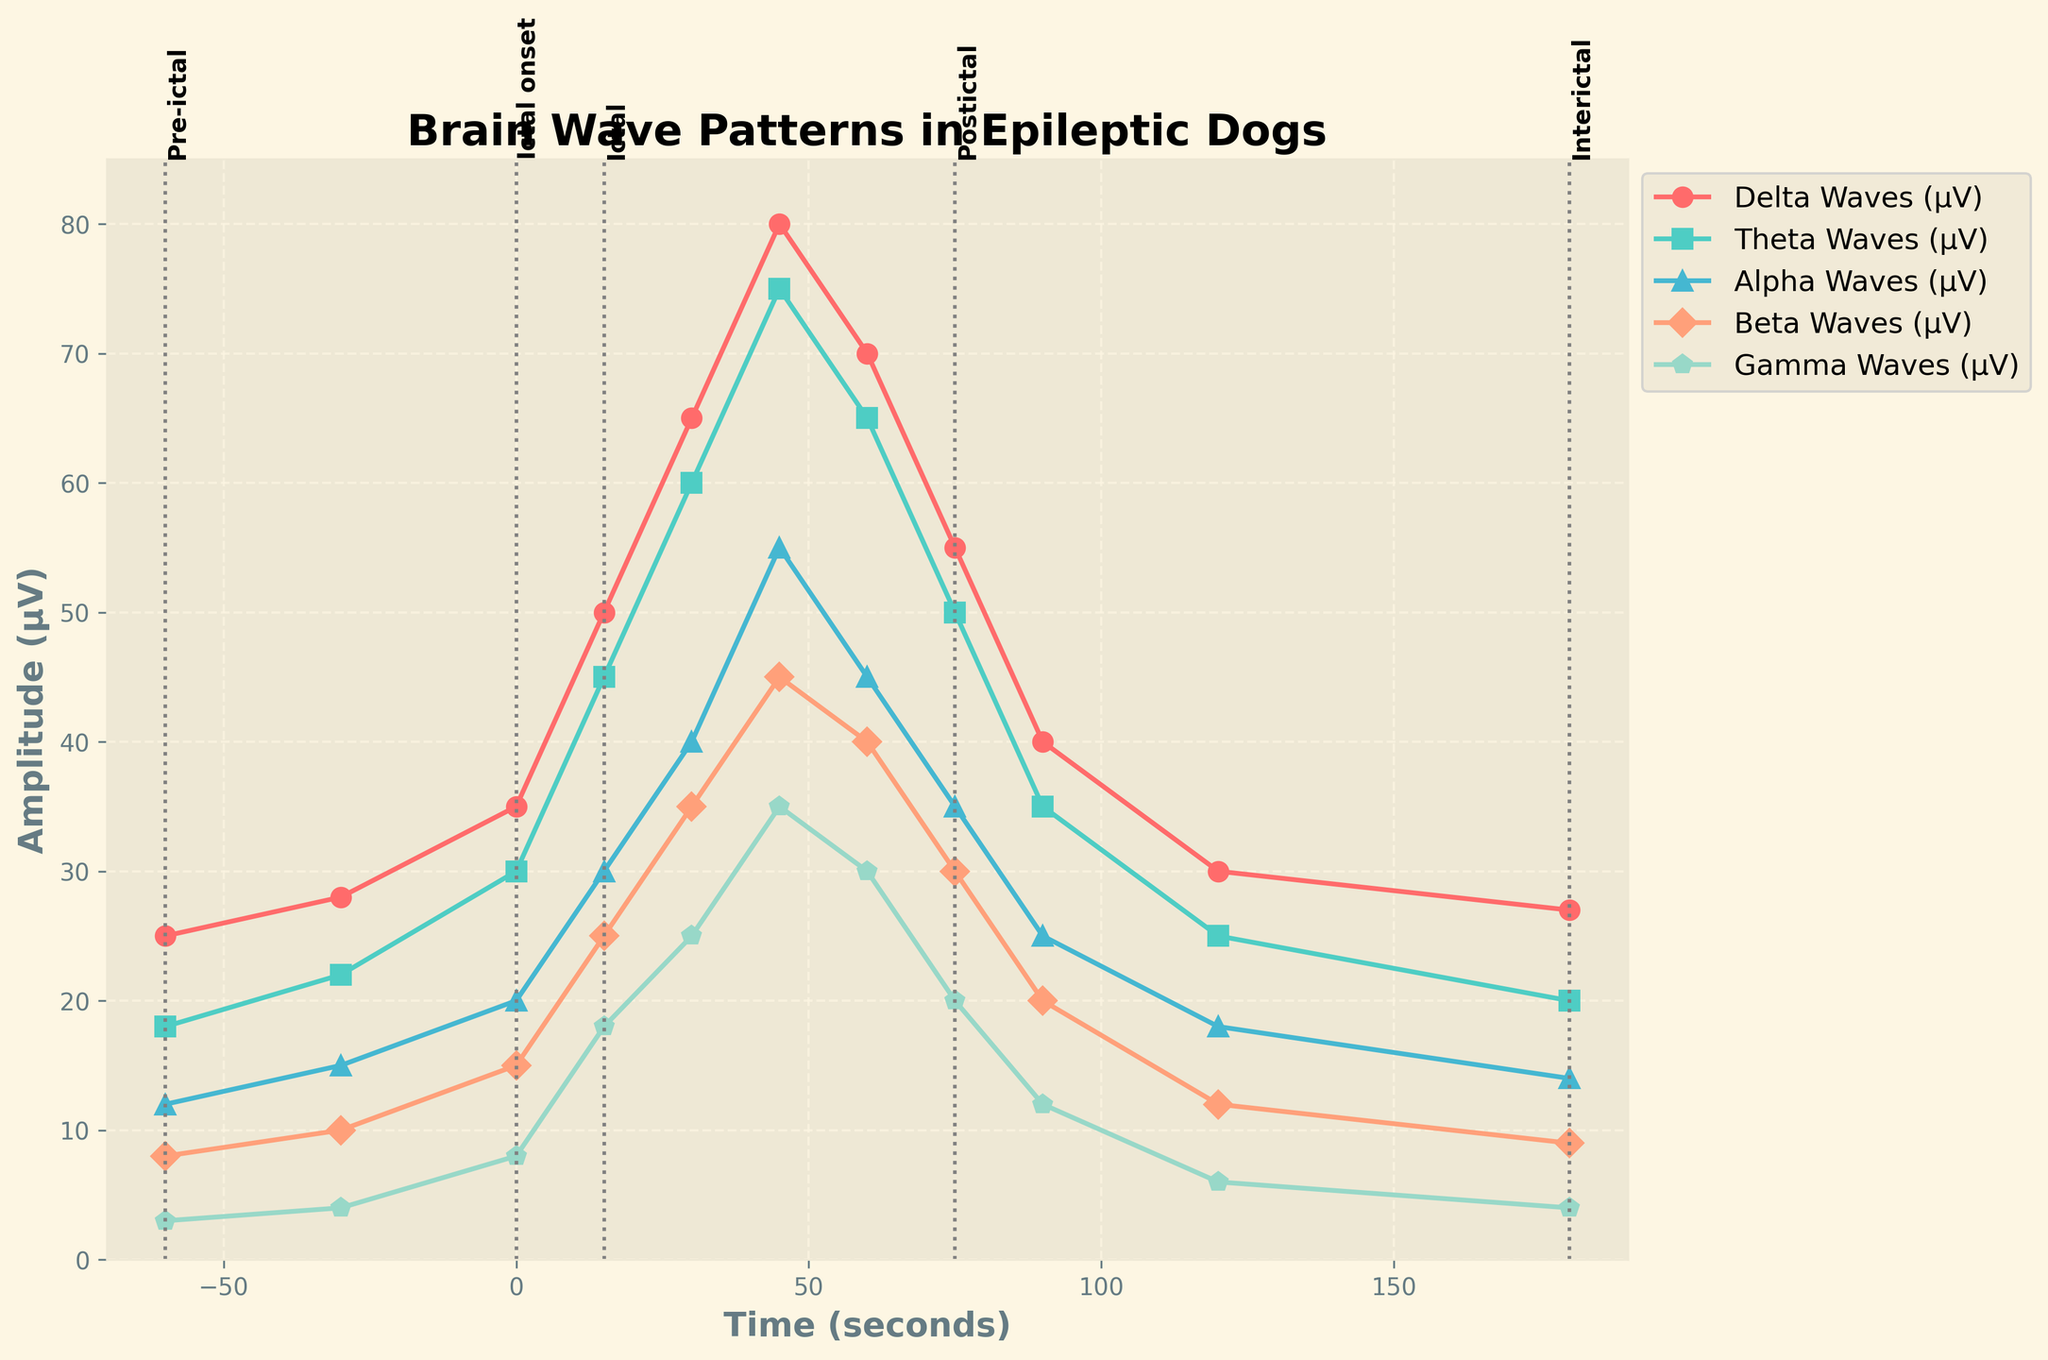Which brain wave type shows the highest peak during the 'Ictal' phase? Visually examine the height of lines corresponding to different brain wave types during the 'Ictal' phase and identify which one has the highest value.
Answer: Delta Waves During which time interval does Beta Waves reach their maximum amplitude? Identify the highest point on the line representing Beta Waves and note the corresponding time on the x-axis.
Answer: 45 seconds How does the amplitude of Gamma Waves change from the 'Pre-ictal' phase to the 'Interictal' phase? Compare the points on the Gamma Waves line during 'Pre-ictal' and 'Interictal' phases. Observe the decrease in amplitude values.
Answer: Decreases Which brain wave shows the steepest increase during the transition from 'Pre-ictal' to 'Ictal onset'? Assess the slopes of the lines from 'Pre-ictal' to 'Ictal onset' and identify which one has the steepest positive slope.
Answer: Delta Waves Compare the amplitude of Theta Waves during 'Ictal onset' and 'Postictal'. How do they differ? Locate the amplitude values for Theta Waves at 'Ictal onset' and 'Postictal' and find the difference.
Answer: Theta Waves decrease from 30 μV at 'Ictal onset' to 50 μV at 'Postictal' At the 60-second mark, how do the amplitudes of Alpha Waves and Gamma Waves compare? Access the amplitude values for Alpha and Gamma Waves at 60 seconds and compare them.
Answer: 45 μV for Alpha Waves, 30 μV for Gamma Waves Between 'Pre-ictal' and 'Postictal' phases, which brain wave type experiences the largest percentage decrease in amplitude? Calculate the percentage decrease in amplitude for each brain wave type from 'Pre-ictal' to 'Postictal' and determine the largest value.
Answer: Gamma Waves What is the average amplitude of Beta Waves during the 'Ictal' phase? Sum the amplitude values of Beta Waves during the 'Ictal' phase and divide by the number of data points.
Answer: 40 μV Compare the Gamma Waves amplitude at 'Ictal onset' and '180 seconds'. How do they vary? Identify the amplitude values for Gamma Waves at 'Ictal onset' and '180 seconds' and compare the two values.
Answer: Gamma Waves decrease from 8 μV to 4 μV 